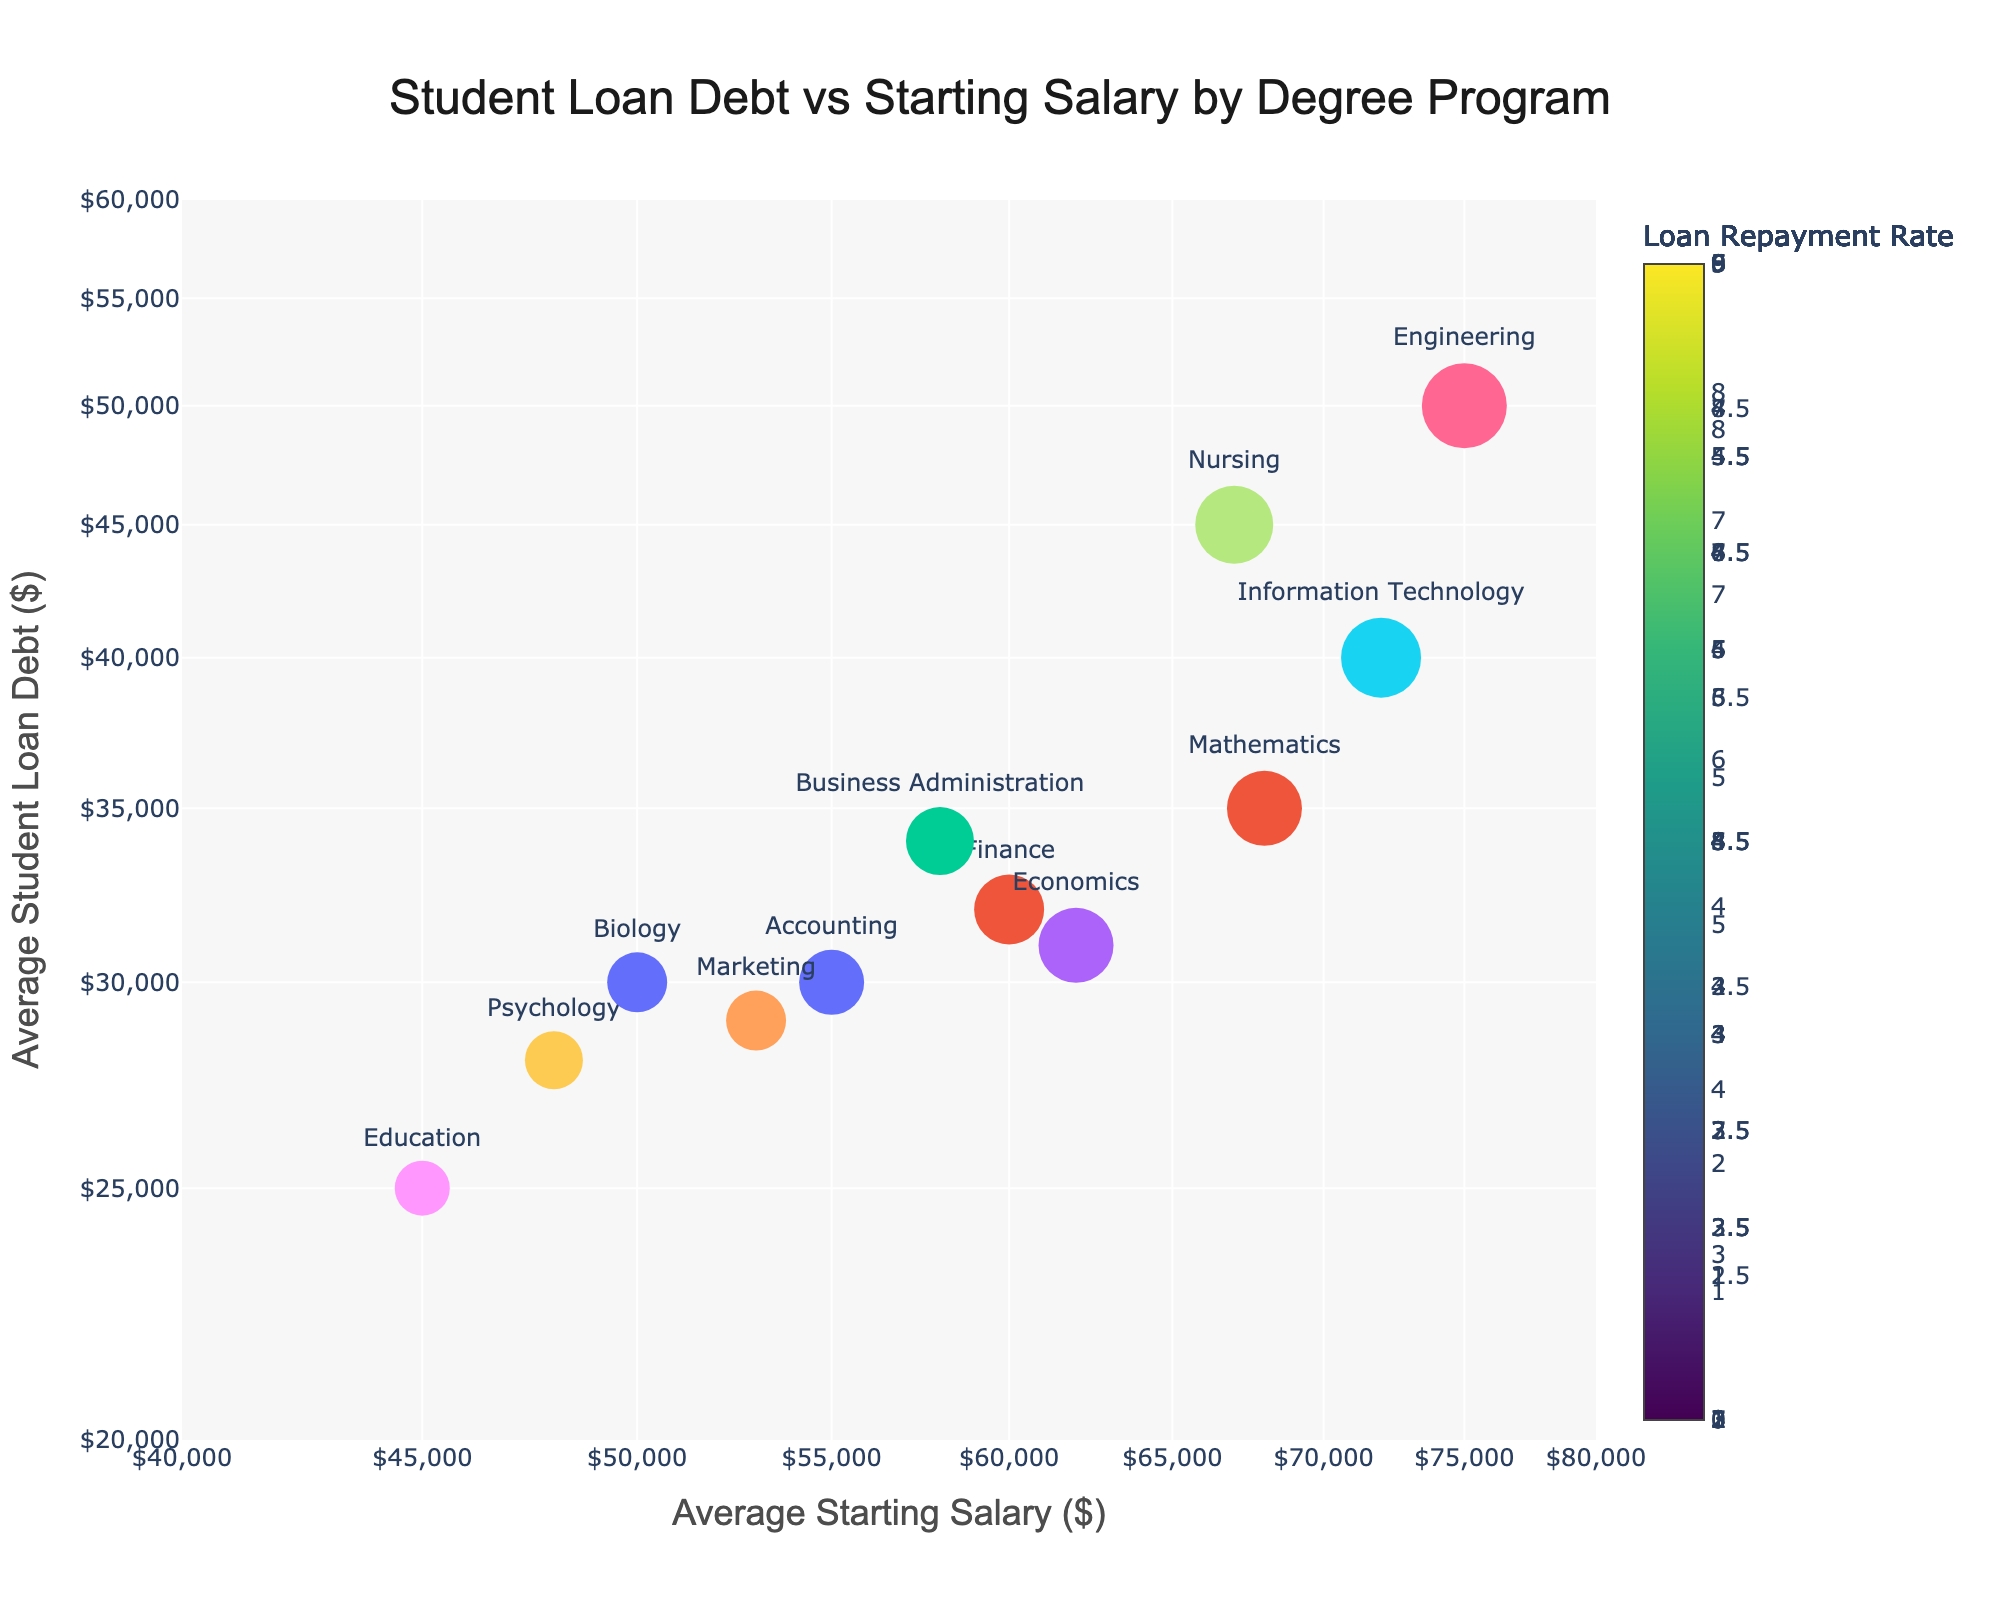What is the title of the figure? The title is typically located at the top of the plot. In this case, it is written in a centralized position in a larger font size than the rest of the text.
Answer: Student Loan Debt vs Starting Salary by Degree Program How many data points are shown in the figure? The number of data points is equal to the number of unique Degree Programs listed in the legend. Count each distinct marker, as each represents a program.
Answer: 12 Which degree program has the highest average starting salary, and what is that salary? Locate the marker farthest to the right on the x-axis, which represents the highest average starting salary. Refer to the text label next to this marker for the degree program name, and note the x-axis value.
Answer: Engineering, $75,000 What is the loan repayment rate represented by the color of the markers? Each marker color is determined by the loan repayment rate, which is shown in the color bar legend on the right side of the plot.
Answer: It varies by program, indicated by the color scale 'Viridis' What is the average student loan debt for the Education degree program? Look for the marker labeled "Education," and by its position on the y-axis (with logarithmic scale), check the approximate value that aligns with the marker's location vertically.
Answer: $25,000 Which degree program has both the lowest average starting salary and student loan debt? Identify the marker closest to the bottom left corner of the plot, representing the lowest values on both x (starting salary) and y (student loan debt) axes. Refer to the text label.
Answer: Education How does the loan repayment rate of Information Technology compare to that of Mathematics? Find and compare the marker sizes and color for "Information Technology" and "Mathematics." The loan repayment rate affects both these attributes.
Answer: Information Technology has a higher repayment rate than Mathematics Which degree programs have an average starting salary of over $60,000? Identify markers positioned to the right of the $60,000 starting salary mark on the x-axis. Refer to their text labels for program names.
Answer: Finance, Economics, Information Technology, Engineering, Nursing, Mathematics What is the relationship between average student loan debt and starting salary for Engineering and Nursing programs? Find the markers for both programs and compare their x (starting salary) and y (student loan debt) axis positions.
Answer: Engineering has higher starting salary and higher student loan debt compared to Nursing What can you infer about the relationship between loan repayment rate and starting salary from the plot? Observe the sizes and colors of the markers; larger and darker-colored markers typically show higher loan repayment rates. Also, consider their distribution across different starting salary ranges on the x-axis.
Answer: Programs with higher starting salaries tend to have higher loan repayment rates 